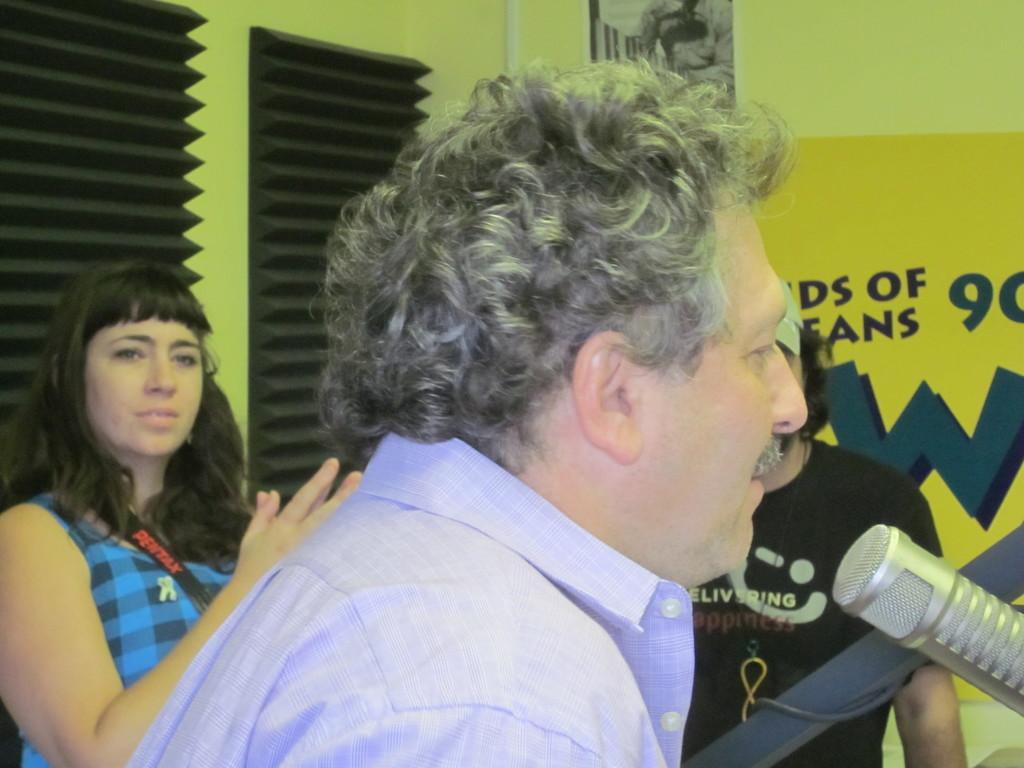What is the man near in the image? The man is near a microphone in the image. Can you describe the woman in the image? There is a woman in the image, but no specific details about her appearance are provided. How many people are present in the image? There is at least one person in the image, as the man near the microphone is mentioned. What can be seen in the background of the image? There are boards and soundproofing foams on the wall in the background of the image. What is the distribution of the sack in the image? There is no sack present in the image. What route does the person take in the image? The image does not depict a person in motion, so there is no route to describe. 